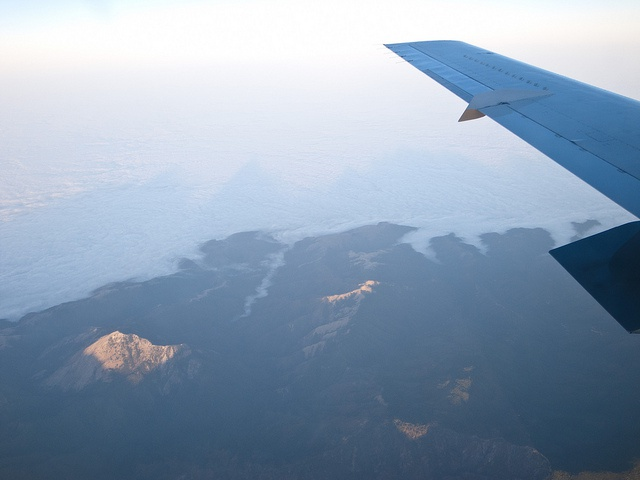Describe the objects in this image and their specific colors. I can see a airplane in lightblue and gray tones in this image. 